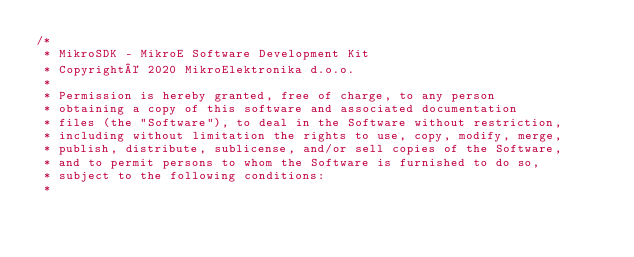<code> <loc_0><loc_0><loc_500><loc_500><_C_>/*
 * MikroSDK - MikroE Software Development Kit
 * Copyright© 2020 MikroElektronika d.o.o.
 * 
 * Permission is hereby granted, free of charge, to any person 
 * obtaining a copy of this software and associated documentation 
 * files (the "Software"), to deal in the Software without restriction, 
 * including without limitation the rights to use, copy, modify, merge, 
 * publish, distribute, sublicense, and/or sell copies of the Software, 
 * and to permit persons to whom the Software is furnished to do so, 
 * subject to the following conditions:
 * </code> 